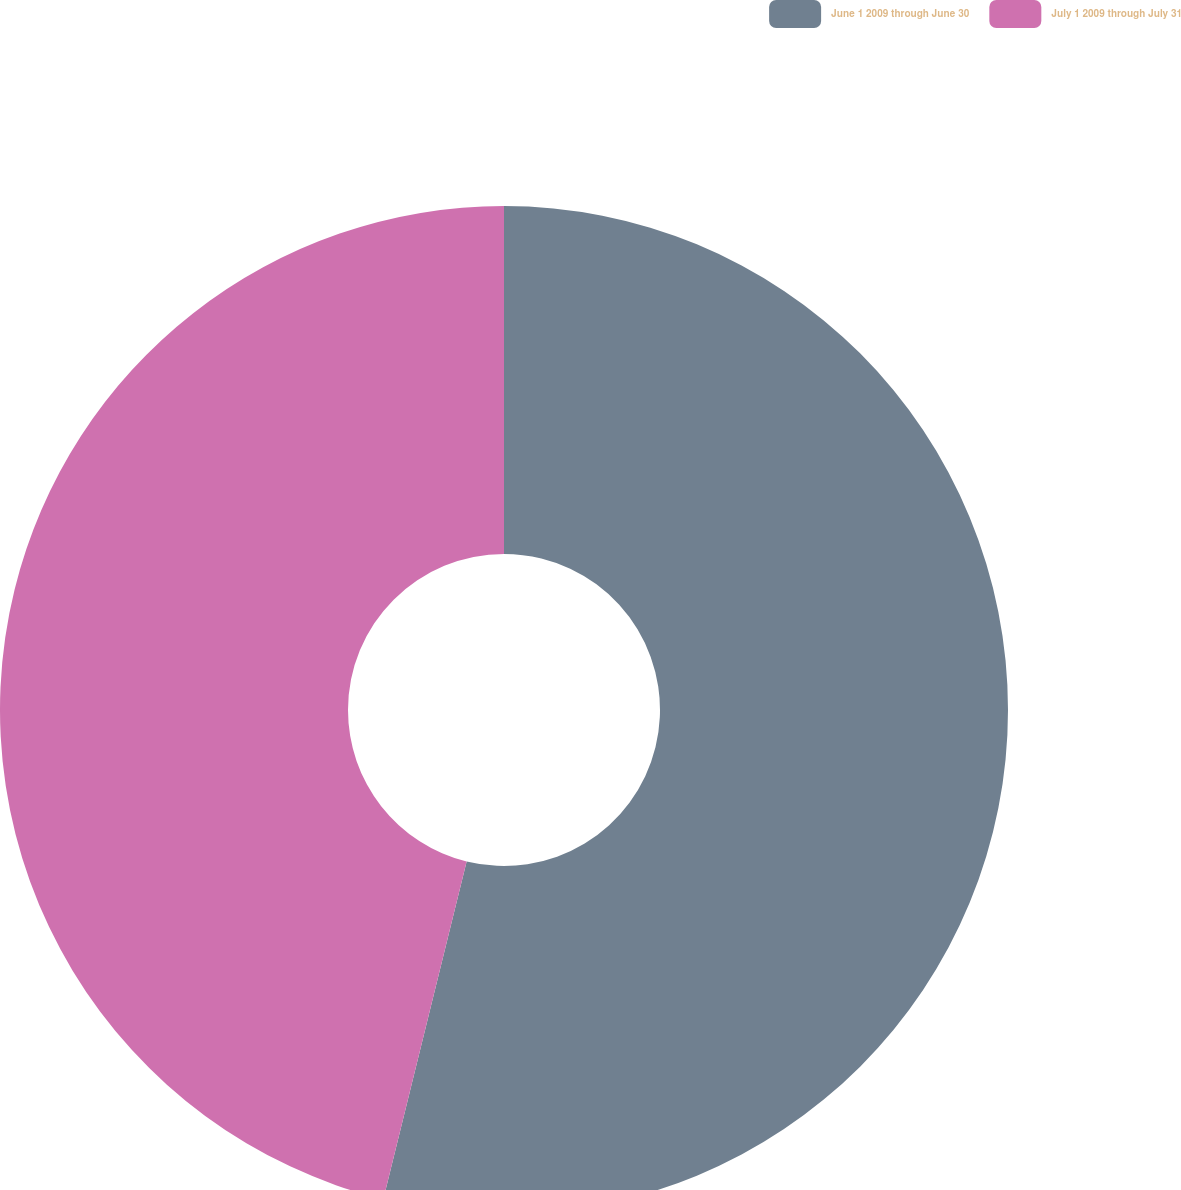<chart> <loc_0><loc_0><loc_500><loc_500><pie_chart><fcel>June 1 2009 through June 30<fcel>July 1 2009 through July 31<nl><fcel>53.85%<fcel>46.15%<nl></chart> 